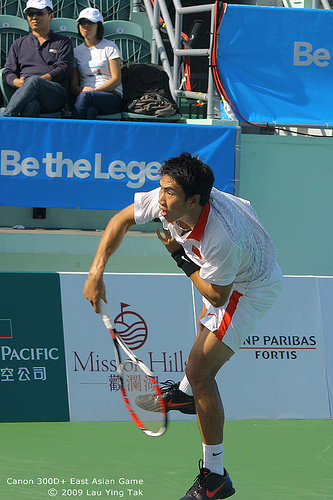Read all the text in this image. Be the Lege PACIFIC Misson 2009 Lau Ying Tok Game Asian Cast 300D Canon Be Hill FORTIS NP PARIBAS 